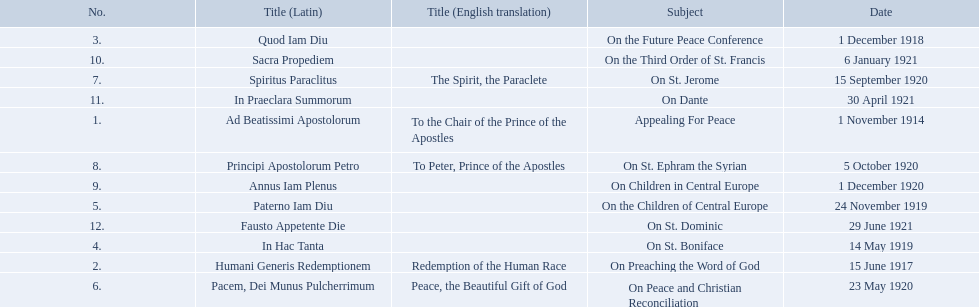What are all the subjects? Appealing For Peace, On Preaching the Word of God, On the Future Peace Conference, On St. Boniface, On the Children of Central Europe, On Peace and Christian Reconciliation, On St. Jerome, On St. Ephram the Syrian, On Children in Central Europe, On the Third Order of St. Francis, On Dante, On St. Dominic. Which occurred in 1920? On Peace and Christian Reconciliation, On St. Jerome, On St. Ephram the Syrian, On Children in Central Europe. Which occurred in may of that year? On Peace and Christian Reconciliation. 